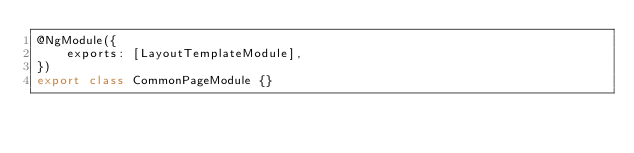<code> <loc_0><loc_0><loc_500><loc_500><_TypeScript_>@NgModule({
    exports: [LayoutTemplateModule],
})
export class CommonPageModule {}
</code> 